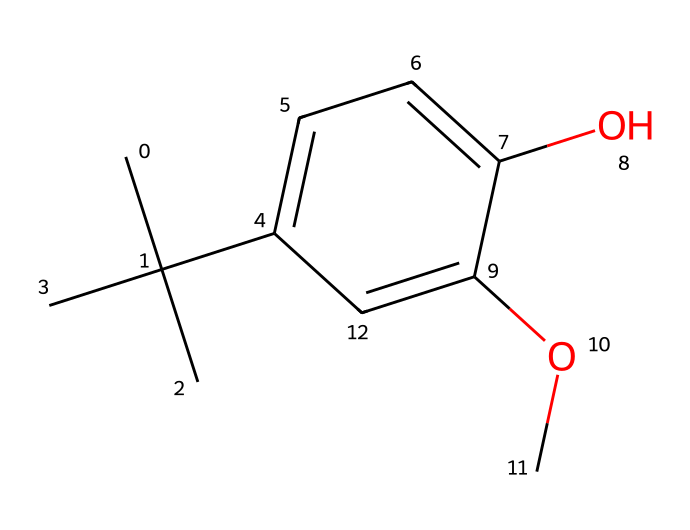What is the name of this chemical? The SMILES representation indicates the structure has a butyl group (CC(C)(C)) and a methoxy group (OC), along with a hydroxyl group (O). This matches the known structure of butylated hydroxyanisole.
Answer: butylated hydroxyanisole How many carbon atoms are in the structure? By interpreting the SMILES, we count 12 carbon atoms from the butyl group (4), the aromatic ring (6), and the methoxy group (1). Thus, the total is 4 + 6 + 1 = 11.
Answer: 11 What type of functional groups are present? In the structure, there is a hydroxyl (-OH) and a methoxy (-OCH3) functional group present. The hydroxyl group is characteristic of phenols, while the methoxy group is an ether.
Answer: hydroxyl and methoxy How many hydrogen atoms are in this compound? From the analysis of the structure, considering the carbon count (11) and the presence of functional groups, we calculate the total number of hydrogens to be 16 using the formula for saturated hydrocarbons adjusted for functional groups.
Answer: 16 What is the main chemical class of butylated hydroxyanisole? The presence of the hydroxyl group on the aromatic ring indicates that the compound belongs to the class of phenols. Additionally, its use as an antioxidant further supports this classification.
Answer: phenol What type of reaction could this compound undergo due to its hydroxyl group? The hydroxyl group can undergo typical reactions of phenolic compounds, including esterification or oxidation, which are characteristic of phenols. This reactivity is due to the electron-donating nature of the hydroxyl group on the aromatic system.
Answer: oxidation 